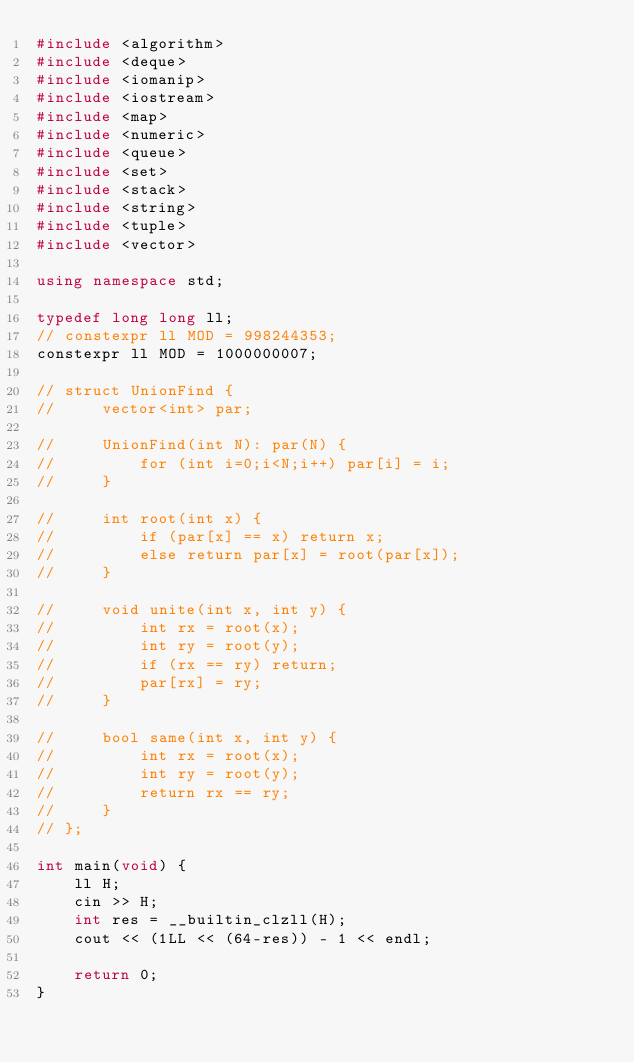Convert code to text. <code><loc_0><loc_0><loc_500><loc_500><_C++_>#include <algorithm>
#include <deque>
#include <iomanip>
#include <iostream>
#include <map>
#include <numeric>
#include <queue>
#include <set>
#include <stack>
#include <string>
#include <tuple>
#include <vector>

using namespace std;

typedef long long ll;
// constexpr ll MOD = 998244353;
constexpr ll MOD = 1000000007;

// struct UnionFind {
//     vector<int> par;
    
//     UnionFind(int N): par(N) {
//         for (int i=0;i<N;i++) par[i] = i;
//     }

//     int root(int x) {
//         if (par[x] == x) return x;
//         else return par[x] = root(par[x]);
//     }

//     void unite(int x, int y) {
//         int rx = root(x);
//         int ry = root(y);
//         if (rx == ry) return;
//         par[rx] = ry;
//     }

//     bool same(int x, int y) {
//         int rx = root(x);
//         int ry = root(y);
//         return rx == ry;
//     }
// };

int main(void) {
    ll H;
    cin >> H;
    int res = __builtin_clzll(H);
    cout << (1LL << (64-res)) - 1 << endl;

    return 0;
}
</code> 